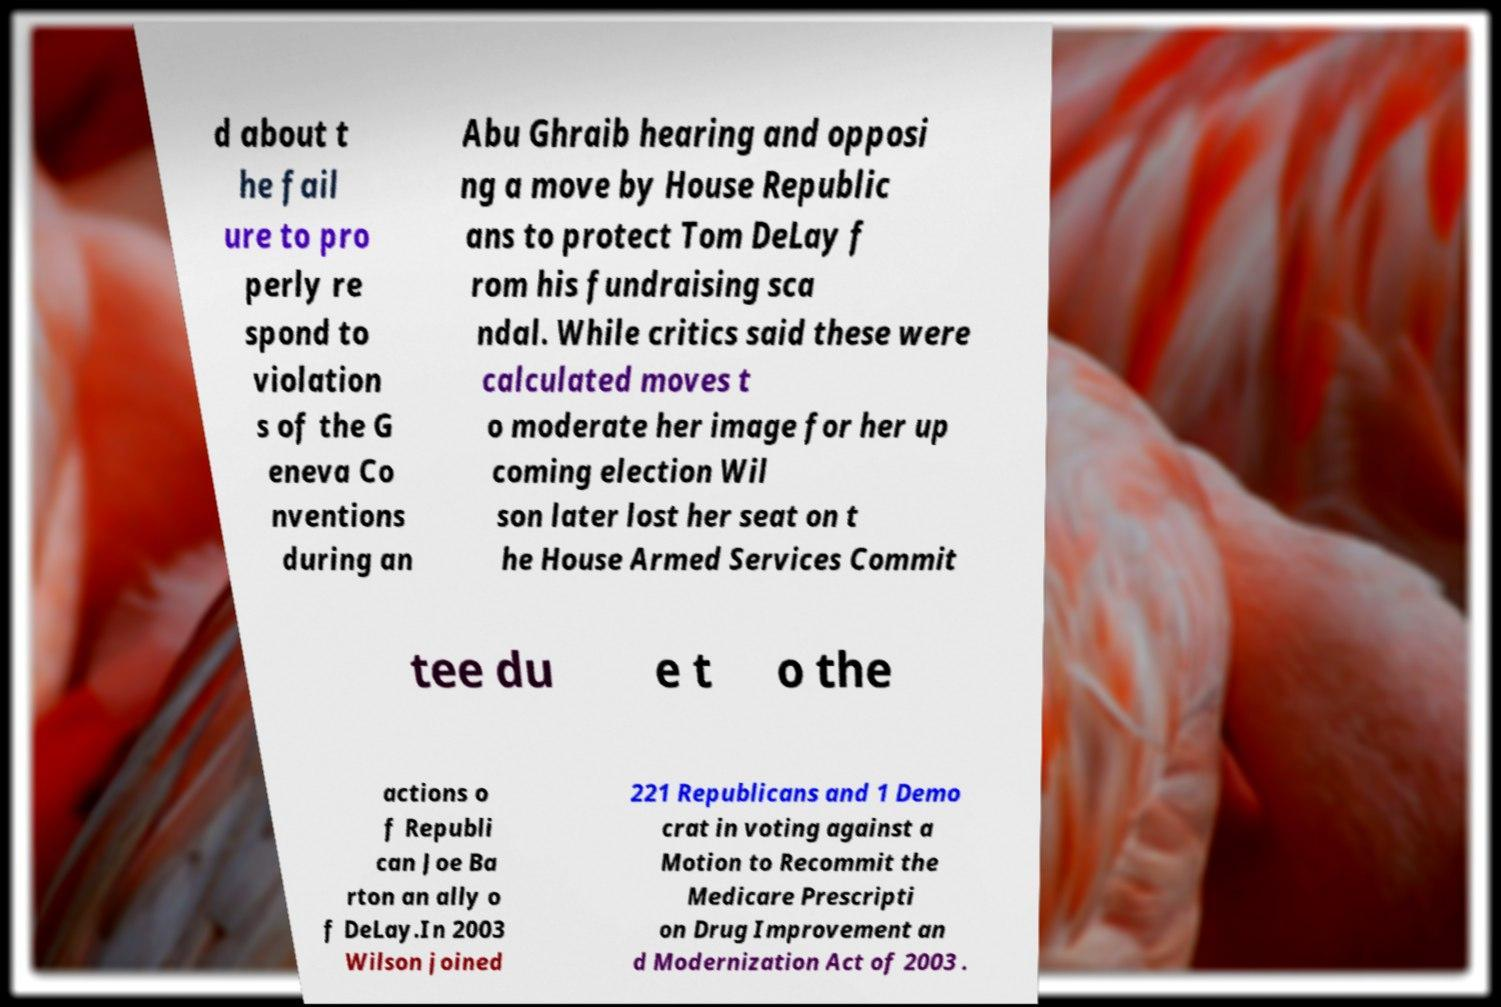Could you extract and type out the text from this image? d about t he fail ure to pro perly re spond to violation s of the G eneva Co nventions during an Abu Ghraib hearing and opposi ng a move by House Republic ans to protect Tom DeLay f rom his fundraising sca ndal. While critics said these were calculated moves t o moderate her image for her up coming election Wil son later lost her seat on t he House Armed Services Commit tee du e t o the actions o f Republi can Joe Ba rton an ally o f DeLay.In 2003 Wilson joined 221 Republicans and 1 Demo crat in voting against a Motion to Recommit the Medicare Prescripti on Drug Improvement an d Modernization Act of 2003 . 